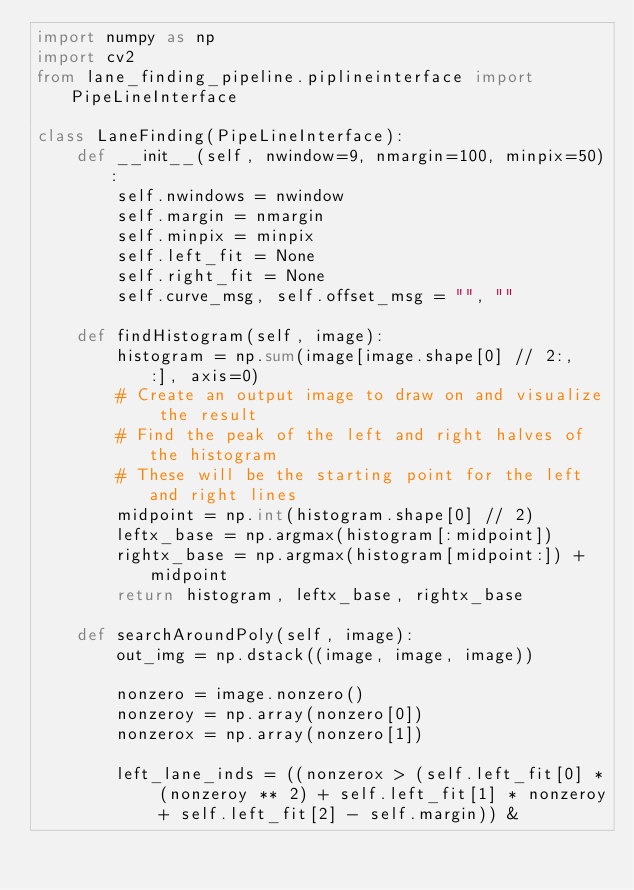Convert code to text. <code><loc_0><loc_0><loc_500><loc_500><_Python_>import numpy as np
import cv2
from lane_finding_pipeline.piplineinterface import PipeLineInterface

class LaneFinding(PipeLineInterface):
    def __init__(self, nwindow=9, nmargin=100, minpix=50):
        self.nwindows = nwindow
        self.margin = nmargin
        self.minpix = minpix
        self.left_fit = None
        self.right_fit = None
        self.curve_msg, self.offset_msg = "", ""

    def findHistogram(self, image):
        histogram = np.sum(image[image.shape[0] // 2:, :], axis=0)
        # Create an output image to draw on and visualize the result
        # Find the peak of the left and right halves of the histogram
        # These will be the starting point for the left and right lines
        midpoint = np.int(histogram.shape[0] // 2)
        leftx_base = np.argmax(histogram[:midpoint])
        rightx_base = np.argmax(histogram[midpoint:]) + midpoint
        return histogram, leftx_base, rightx_base

    def searchAroundPoly(self, image):
        out_img = np.dstack((image, image, image))

        nonzero = image.nonzero()
        nonzeroy = np.array(nonzero[0])
        nonzerox = np.array(nonzero[1])

        left_lane_inds = ((nonzerox > (self.left_fit[0] * (nonzeroy ** 2) + self.left_fit[1] * nonzeroy + self.left_fit[2] - self.margin)) &</code> 